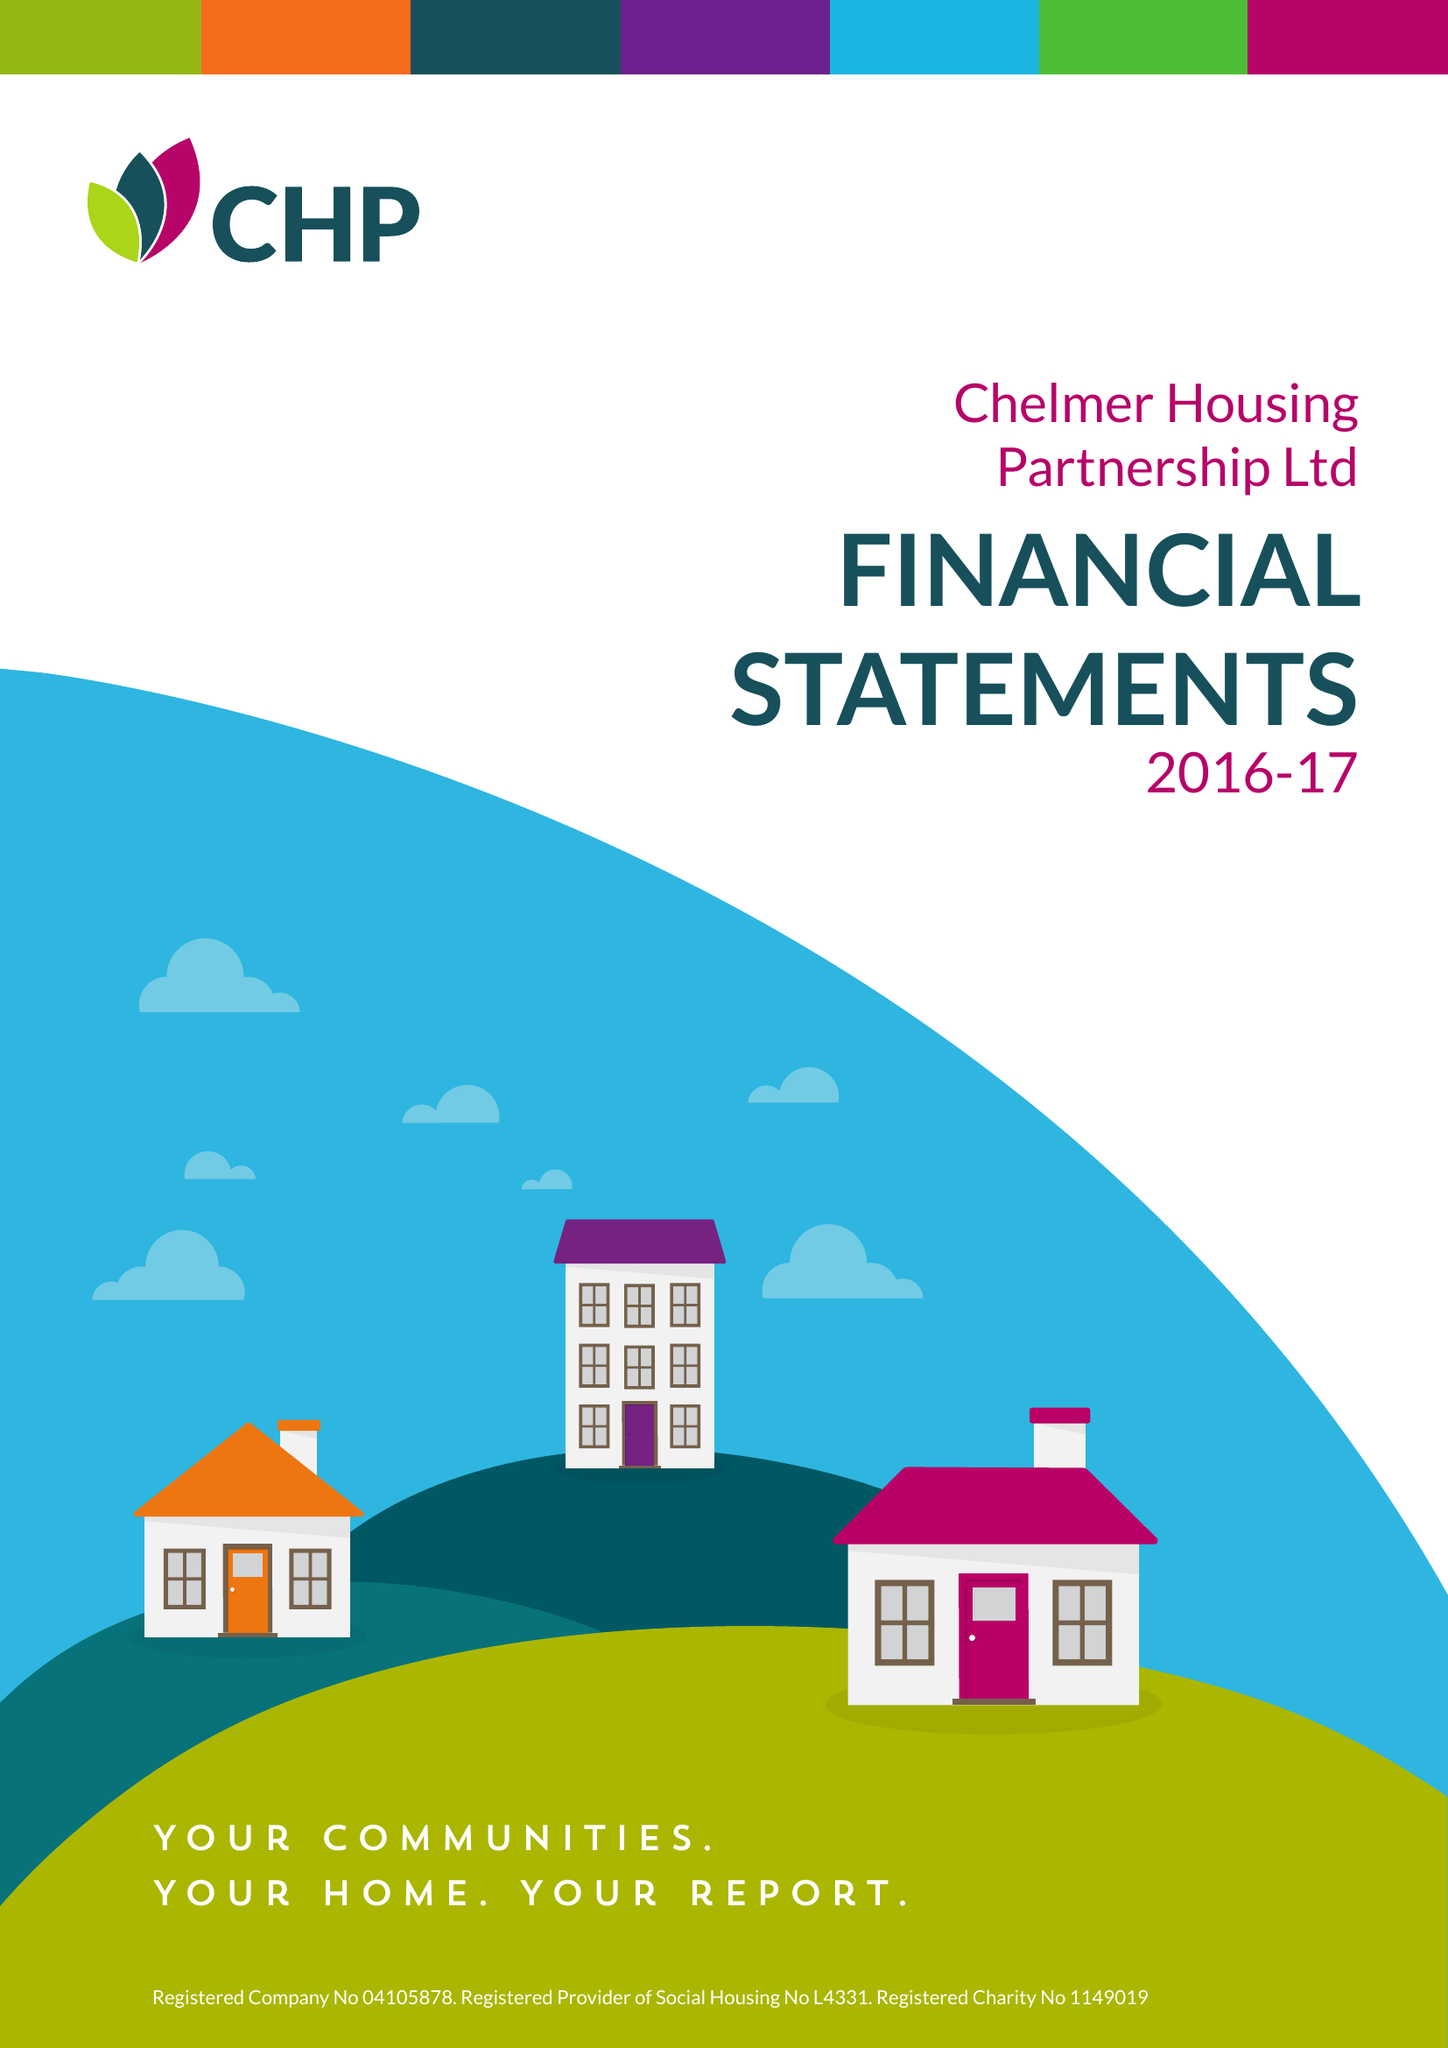What is the value for the spending_annually_in_british_pounds?
Answer the question using a single word or phrase. 53052000.00 